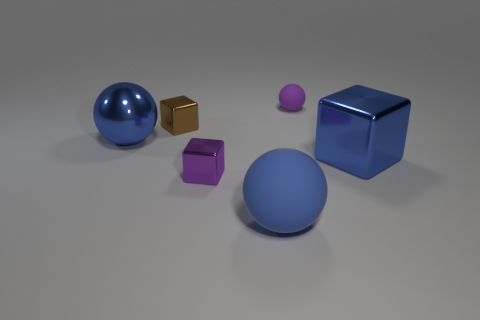How many blue balls must be subtracted to get 1 blue balls? 1 Subtract all small cubes. How many cubes are left? 1 Add 1 small things. How many objects exist? 7 Subtract all purple spheres. How many spheres are left? 2 Add 5 tiny blocks. How many tiny blocks exist? 7 Subtract 1 brown cubes. How many objects are left? 5 Subtract 3 spheres. How many spheres are left? 0 Subtract all green cubes. Subtract all brown balls. How many cubes are left? 3 Subtract all red blocks. How many cyan spheres are left? 0 Subtract all small brown metallic things. Subtract all big blue rubber spheres. How many objects are left? 4 